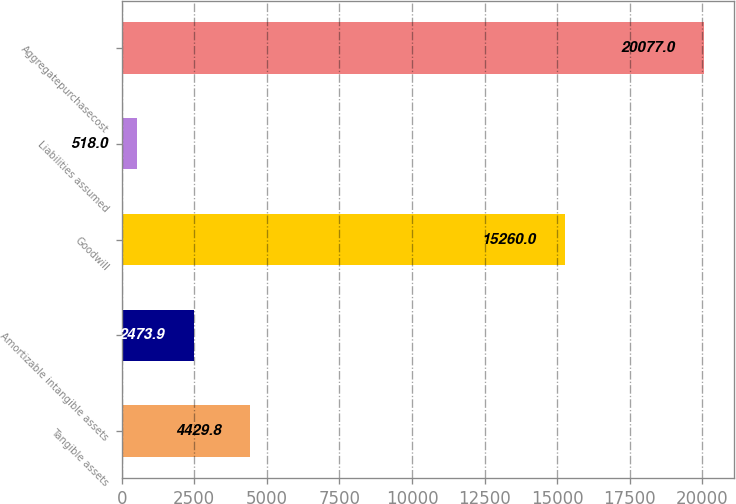<chart> <loc_0><loc_0><loc_500><loc_500><bar_chart><fcel>Tangible assets<fcel>Amortizable intangible assets<fcel>Goodwill<fcel>Liabilities assumed<fcel>Aggregatepurchasecost<nl><fcel>4429.8<fcel>2473.9<fcel>15260<fcel>518<fcel>20077<nl></chart> 